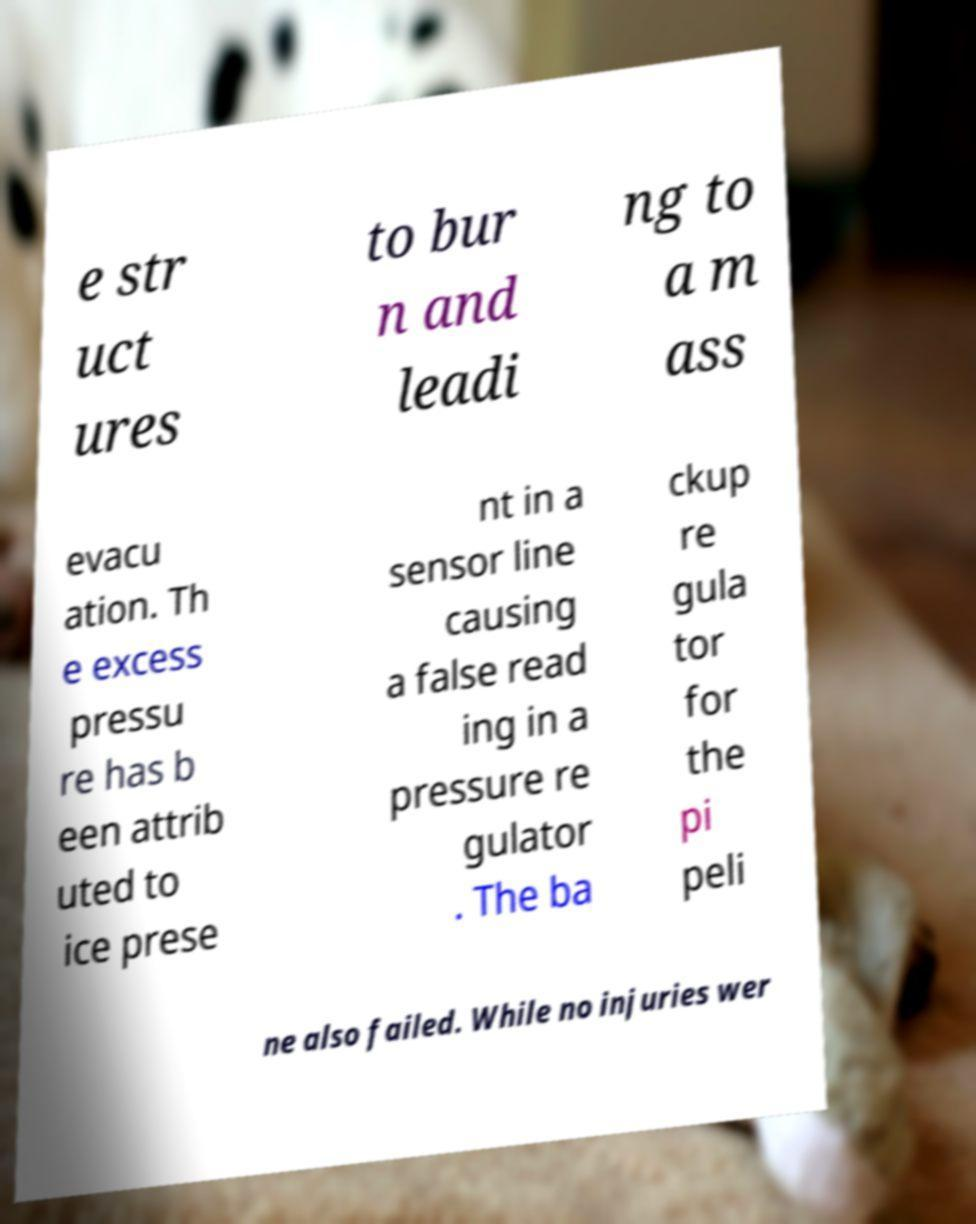Can you read and provide the text displayed in the image?This photo seems to have some interesting text. Can you extract and type it out for me? e str uct ures to bur n and leadi ng to a m ass evacu ation. Th e excess pressu re has b een attrib uted to ice prese nt in a sensor line causing a false read ing in a pressure re gulator . The ba ckup re gula tor for the pi peli ne also failed. While no injuries wer 